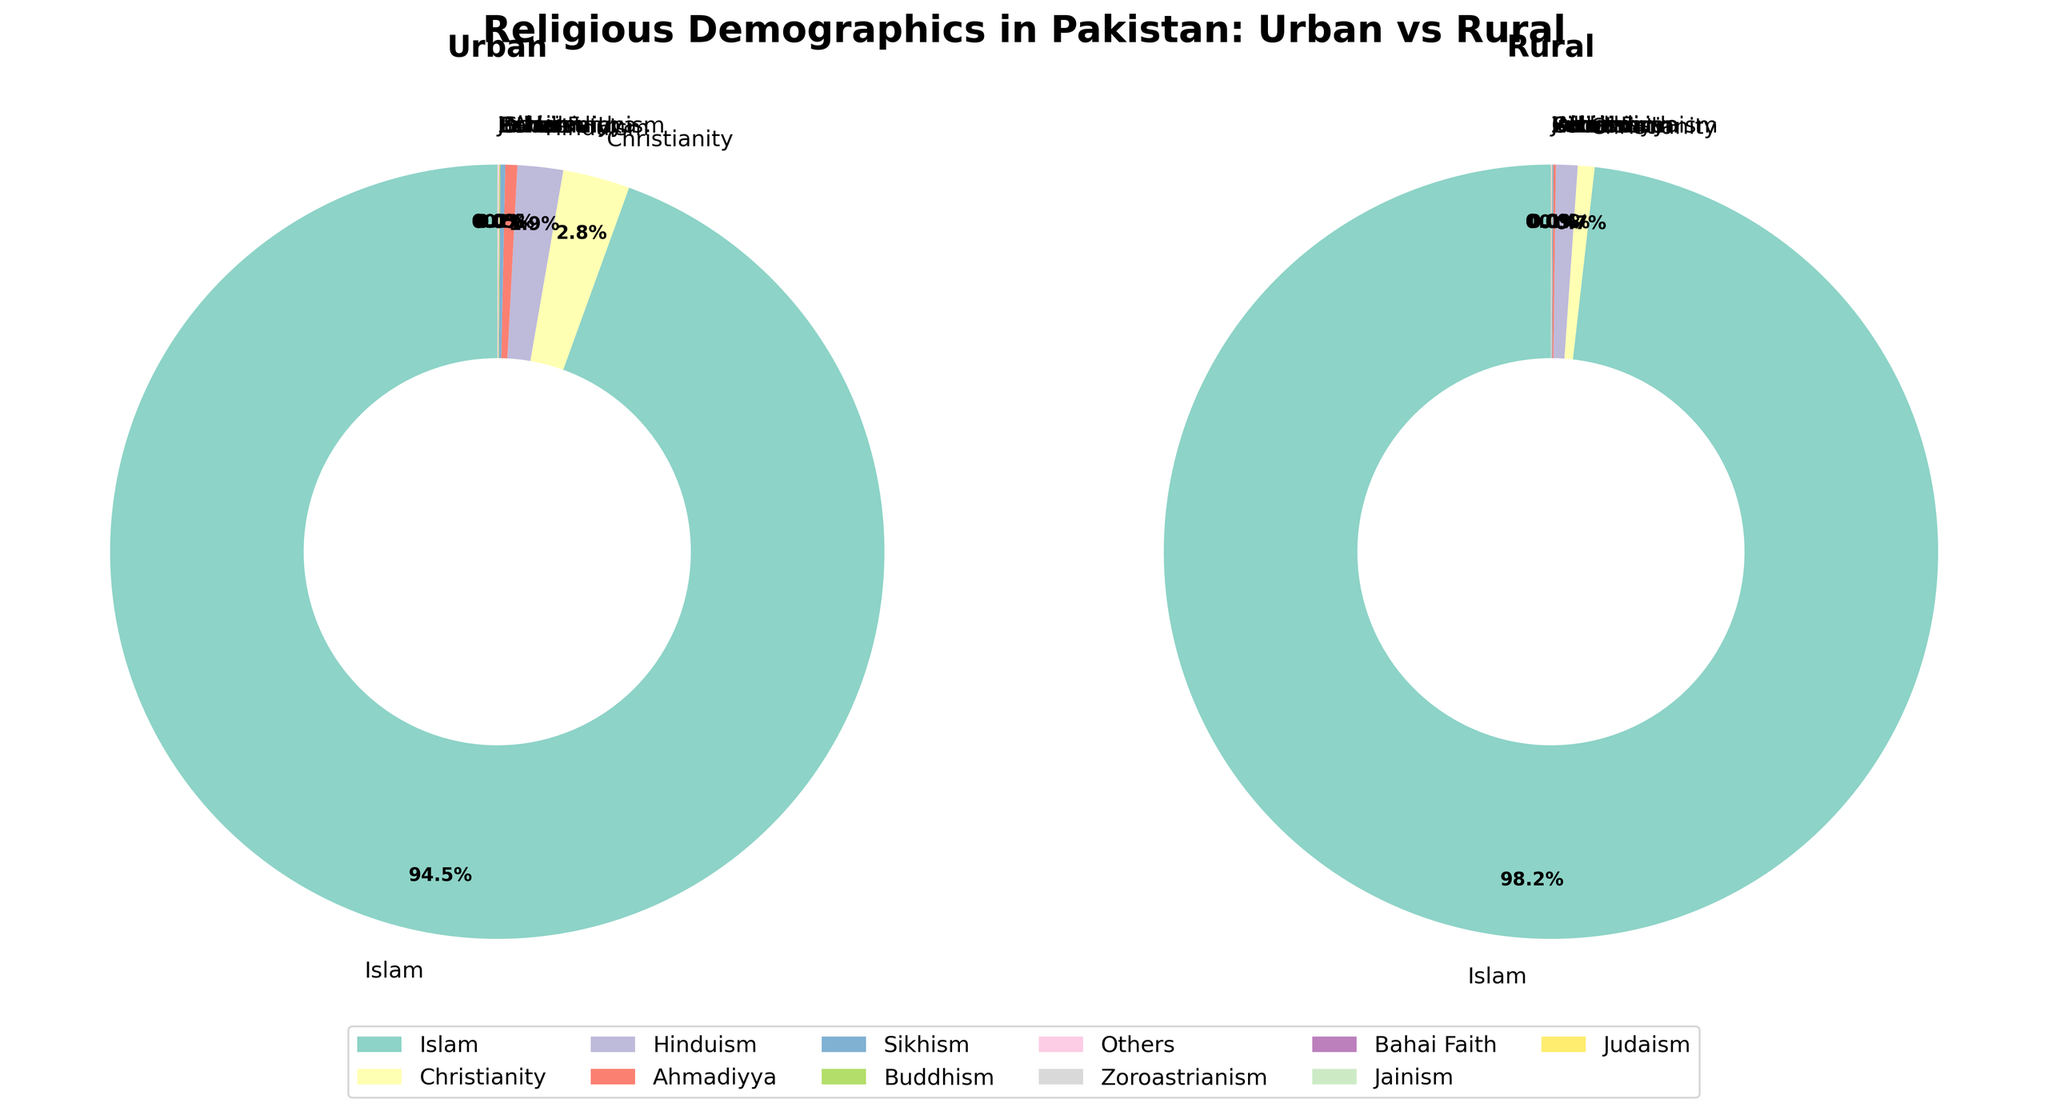Which religion has the largest percentage difference between urban and rural areas? To find the religion with the largest percentage difference between urban and rural areas, subtract the rural percentage from the urban percentage for each religion. The biggest difference is found in Islam, with a difference of 98.2 - 94.5 = 3.7%.
Answer: Islam Which religious group has the smallest representation in urban areas? Identify the religion with the smallest percentage in the urban column. According to the data, Zoroastrianism, Bahai Faith, Jainism, and Judaism each have a percentage of 0.005%.
Answer: Zoroastrianism, Bahai Faith, Jainism, Judaism How does the percentage of Christianity in urban areas compare to rural areas? Compare the values of Christianity in urban and rural columns. Christianity in urban areas is 2.8%, and in rural areas, it is 0.7%. Thus, it is significantly higher in urban areas compared to rural areas.
Answer: Higher in urban areas Which has a higher percentage in rural areas: Hinduism or Ahmadiyya? Compare the percentages of Hinduism (0.9%) and Ahmadiyya (0.1%) in rural areas. Hinduism has a higher percentage.
Answer: Hinduism What is the combined percentage of Sikhism, Buddhism, and others in urban areas? Add the percentages of Sikhism (0.2%), Buddhism (0.05%), and others (0.05%) in urban areas. The combined percentage is 0.2% + 0.05% + 0.05% = 0.3%.
Answer: 0.3% In rural areas, is the percentage of followers of "Others" religion greater than or less than 0.1%? The data for "Others" in rural shows a percentage of 0.03%. This is less than 0.1%.
Answer: Less than 0.1% What is the total percentage of non-Islamic religions in urban areas? Subtract the percentage of Islam in urban areas from 100%. 100% - 94.5% = 5.5%.
Answer: 5.5% Is the percentage of Hinduism in urban areas greater than twice its percentage in rural areas? The percentage of Hinduism in urban areas is 1.9%, and twice the rural percentage of 0.9% is 1.8%. Since 1.9% > 1.8%, Hinduism in urban areas is greater than twice its percentage in rural areas.
Answer: Yes Which religion has the least percentage difference between urban and rural areas? Calculate the percentage differences between urban and rural areas for each religion and find the smallest difference. Jainism and Judaism both have differences of 0.005% - 0.001% = 0.004%.
Answer: Jainism, Judaism 